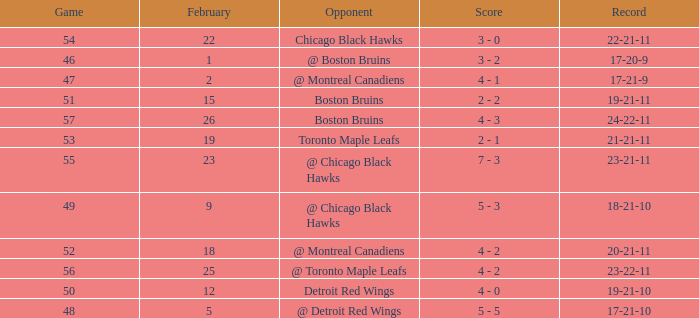What was the tally of the contest 57 after february 23? 4 - 3. 